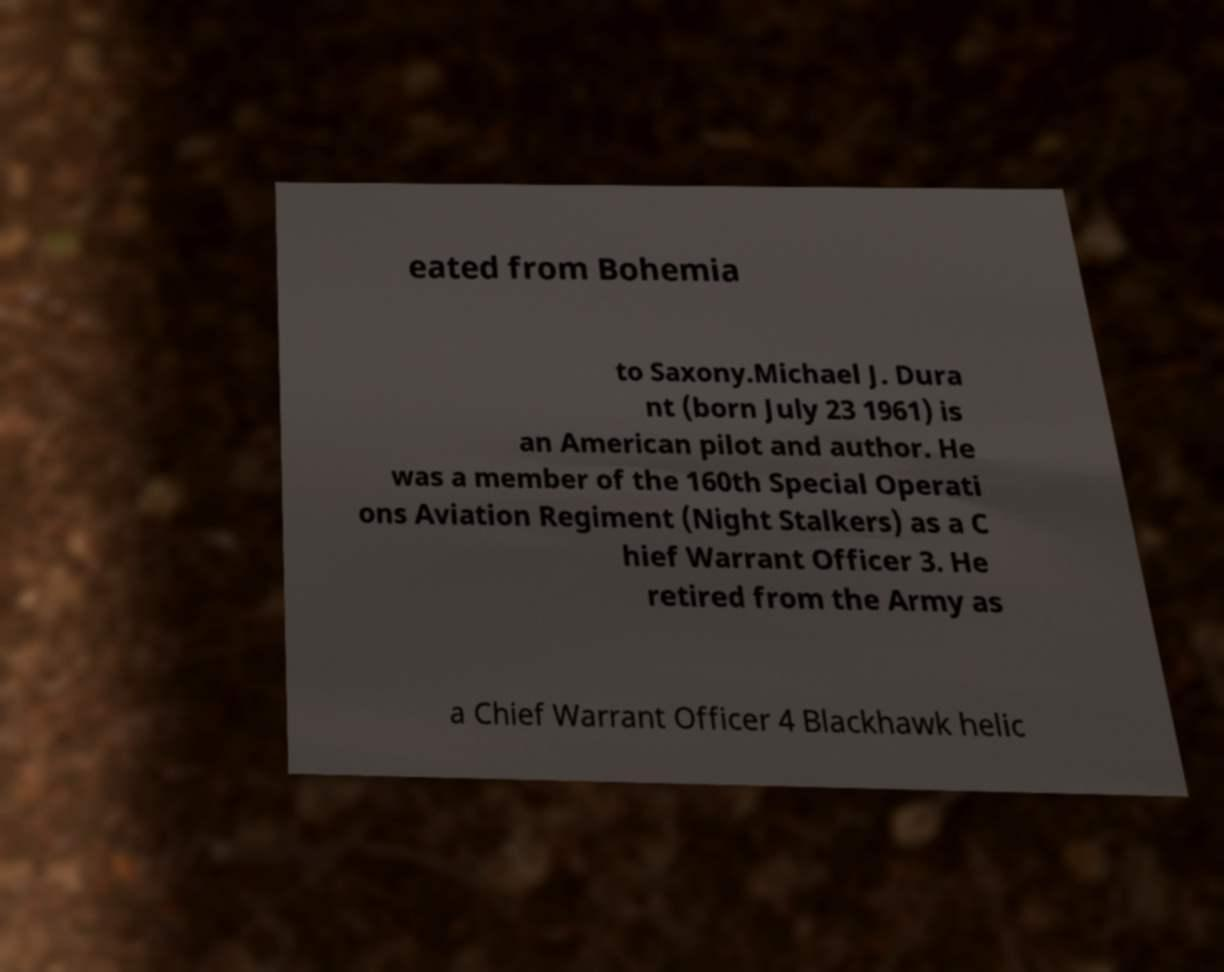Could you assist in decoding the text presented in this image and type it out clearly? eated from Bohemia to Saxony.Michael J. Dura nt (born July 23 1961) is an American pilot and author. He was a member of the 160th Special Operati ons Aviation Regiment (Night Stalkers) as a C hief Warrant Officer 3. He retired from the Army as a Chief Warrant Officer 4 Blackhawk helic 